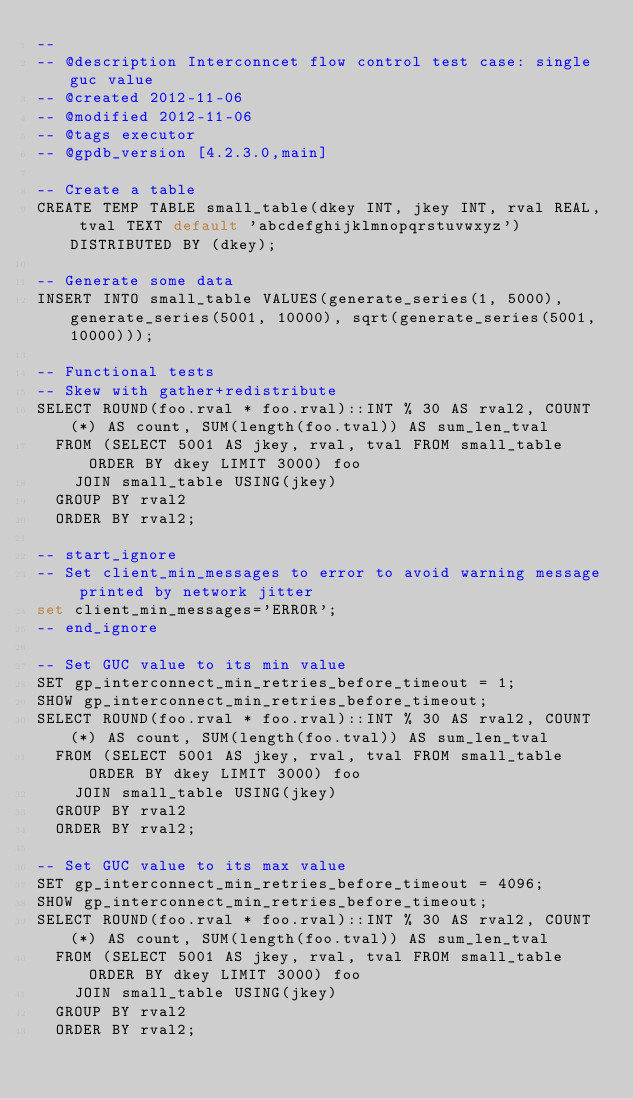Convert code to text. <code><loc_0><loc_0><loc_500><loc_500><_SQL_>-- 
-- @description Interconncet flow control test case: single guc value
-- @created 2012-11-06
-- @modified 2012-11-06
-- @tags executor
-- @gpdb_version [4.2.3.0,main]

-- Create a table
CREATE TEMP TABLE small_table(dkey INT, jkey INT, rval REAL, tval TEXT default 'abcdefghijklmnopqrstuvwxyz') DISTRIBUTED BY (dkey);

-- Generate some data
INSERT INTO small_table VALUES(generate_series(1, 5000), generate_series(5001, 10000), sqrt(generate_series(5001, 10000)));

-- Functional tests
-- Skew with gather+redistribute
SELECT ROUND(foo.rval * foo.rval)::INT % 30 AS rval2, COUNT(*) AS count, SUM(length(foo.tval)) AS sum_len_tval
  FROM (SELECT 5001 AS jkey, rval, tval FROM small_table ORDER BY dkey LIMIT 3000) foo
    JOIN small_table USING(jkey)
  GROUP BY rval2
  ORDER BY rval2;

-- start_ignore
-- Set client_min_messages to error to avoid warning message printed by network jitter
set client_min_messages='ERROR';
-- end_ignore

-- Set GUC value to its min value 
SET gp_interconnect_min_retries_before_timeout = 1;
SHOW gp_interconnect_min_retries_before_timeout;
SELECT ROUND(foo.rval * foo.rval)::INT % 30 AS rval2, COUNT(*) AS count, SUM(length(foo.tval)) AS sum_len_tval
  FROM (SELECT 5001 AS jkey, rval, tval FROM small_table ORDER BY dkey LIMIT 3000) foo
    JOIN small_table USING(jkey)
  GROUP BY rval2
  ORDER BY rval2;

-- Set GUC value to its max value
SET gp_interconnect_min_retries_before_timeout = 4096;
SHOW gp_interconnect_min_retries_before_timeout;
SELECT ROUND(foo.rval * foo.rval)::INT % 30 AS rval2, COUNT(*) AS count, SUM(length(foo.tval)) AS sum_len_tval
  FROM (SELECT 5001 AS jkey, rval, tval FROM small_table ORDER BY dkey LIMIT 3000) foo
    JOIN small_table USING(jkey)
  GROUP BY rval2
  ORDER BY rval2;
</code> 